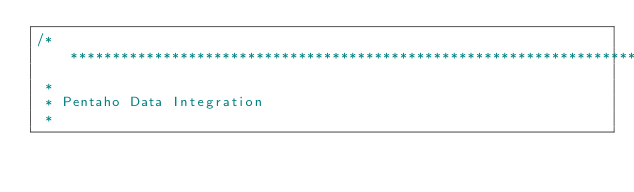<code> <loc_0><loc_0><loc_500><loc_500><_Java_>/*******************************************************************************
 *
 * Pentaho Data Integration
 *</code> 